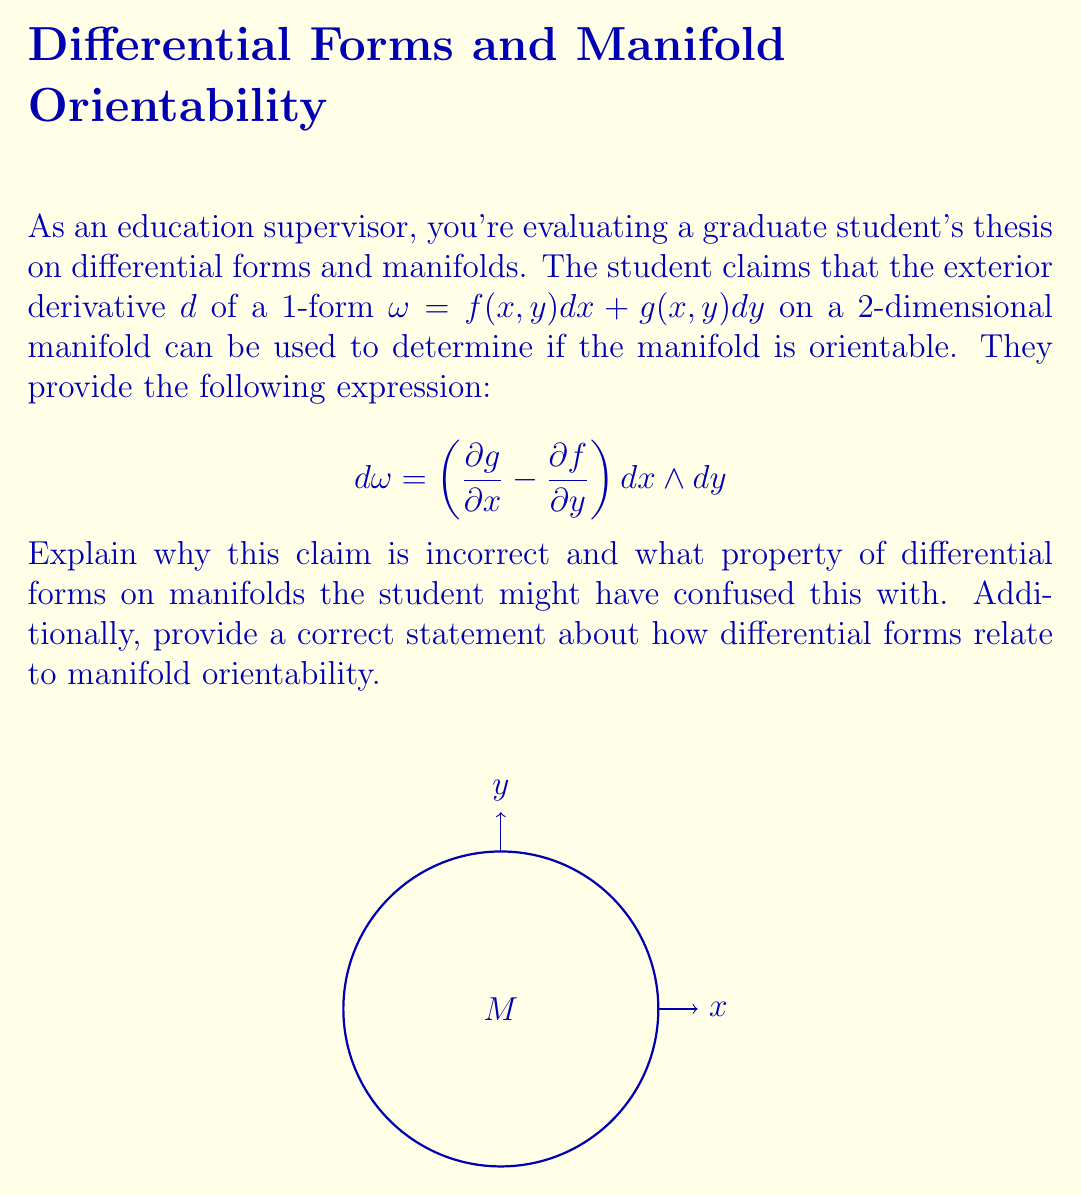Show me your answer to this math problem. Let's break this down step-by-step:

1) The student's claim is incorrect because the exterior derivative of a 1-form doesn't determine the orientability of a manifold. Here's why:

   a) The exterior derivative $d\omega$ is always well-defined for any smooth 1-form $\omega$ on any smooth manifold, regardless of orientability.
   
   b) The expression $d\omega = \left(\frac{\partial g}{\partial x} - \frac{\partial f}{\partial y}\right) dx \wedge dy$ is correct, but it doesn't imply anything about orientability.

2) The student might have confused this with the concept of a volume form on an orientable manifold:

   a) On an n-dimensional orientable manifold, there exists a nowhere-vanishing n-form called a volume form.
   
   b) For a 2-dimensional manifold, a volume form would be a nowhere-vanishing 2-form, which locally looks like $f(x,y)dx \wedge dy$ where $f(x,y) \neq 0$ everywhere.

3) The correct statement relating differential forms to manifold orientability is:

   A smooth n-dimensional manifold M is orientable if and only if there exists a smooth, nowhere-vanishing n-form on M.

4) In the context of the original problem:

   a) The existence of the 2-form $d\omega$ doesn't imply orientability because $d\omega$ could vanish at some points.
   
   b) Even if $d\omega$ is nowhere-vanishing, its existence is not equivalent to orientability because $d\omega$ is derived from a globally defined 1-form $\omega$, which exists on both orientable and non-orientable manifolds.

5) To determine orientability using differential forms, one would need to show the existence of a globally defined, nowhere-vanishing n-form (where n is the dimension of the manifold), not just the exterior derivative of a lower-degree form.
Answer: The claim is incorrect because the exterior derivative of a 1-form doesn't determine manifold orientability. A manifold is orientable if and only if it admits a nowhere-vanishing top-degree form. 